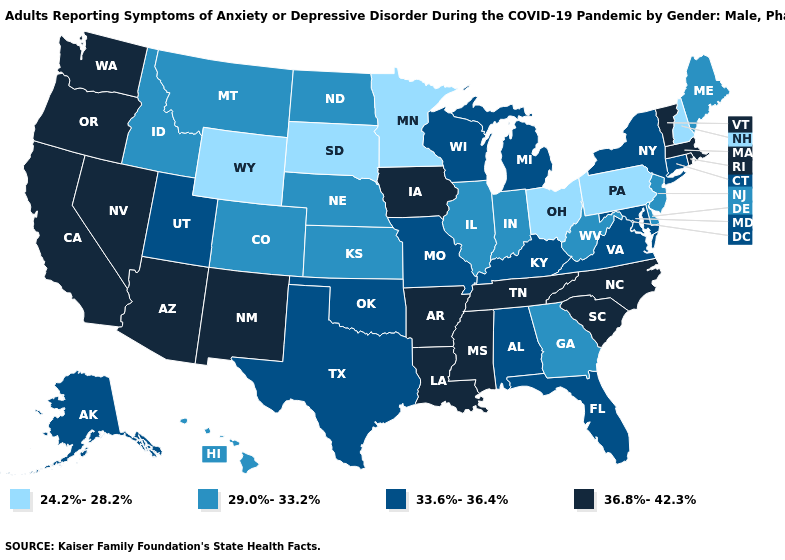Name the states that have a value in the range 33.6%-36.4%?
Concise answer only. Alabama, Alaska, Connecticut, Florida, Kentucky, Maryland, Michigan, Missouri, New York, Oklahoma, Texas, Utah, Virginia, Wisconsin. Name the states that have a value in the range 29.0%-33.2%?
Keep it brief. Colorado, Delaware, Georgia, Hawaii, Idaho, Illinois, Indiana, Kansas, Maine, Montana, Nebraska, New Jersey, North Dakota, West Virginia. Name the states that have a value in the range 24.2%-28.2%?
Short answer required. Minnesota, New Hampshire, Ohio, Pennsylvania, South Dakota, Wyoming. What is the value of Florida?
Keep it brief. 33.6%-36.4%. What is the value of Indiana?
Be succinct. 29.0%-33.2%. Which states have the lowest value in the Northeast?
Give a very brief answer. New Hampshire, Pennsylvania. Name the states that have a value in the range 29.0%-33.2%?
Give a very brief answer. Colorado, Delaware, Georgia, Hawaii, Idaho, Illinois, Indiana, Kansas, Maine, Montana, Nebraska, New Jersey, North Dakota, West Virginia. Name the states that have a value in the range 33.6%-36.4%?
Write a very short answer. Alabama, Alaska, Connecticut, Florida, Kentucky, Maryland, Michigan, Missouri, New York, Oklahoma, Texas, Utah, Virginia, Wisconsin. Among the states that border South Dakota , does Iowa have the highest value?
Write a very short answer. Yes. Name the states that have a value in the range 33.6%-36.4%?
Answer briefly. Alabama, Alaska, Connecticut, Florida, Kentucky, Maryland, Michigan, Missouri, New York, Oklahoma, Texas, Utah, Virginia, Wisconsin. What is the value of Idaho?
Quick response, please. 29.0%-33.2%. What is the value of Arizona?
Answer briefly. 36.8%-42.3%. Among the states that border North Carolina , does Georgia have the lowest value?
Concise answer only. Yes. Which states have the lowest value in the MidWest?
Be succinct. Minnesota, Ohio, South Dakota. Among the states that border North Carolina , does Georgia have the lowest value?
Give a very brief answer. Yes. 